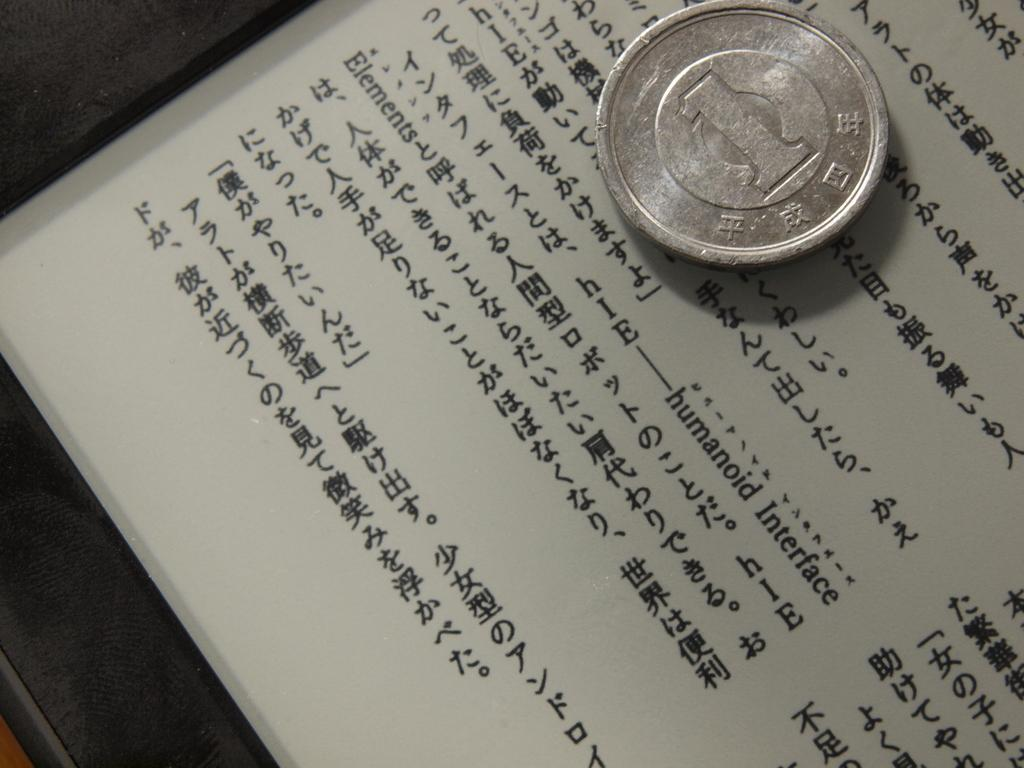<image>
Summarize the visual content of the image. A 1 unit coin from Asia is on a text about humanoid interface elements. 